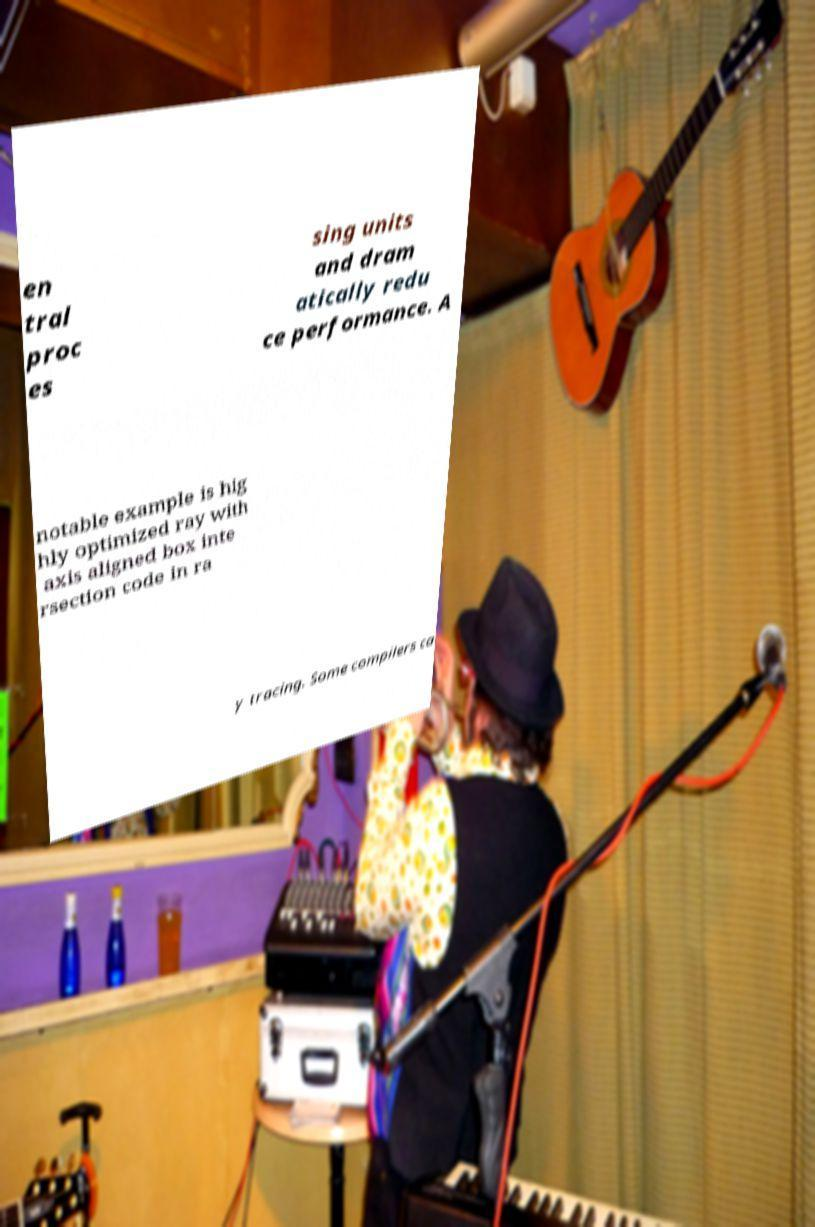For documentation purposes, I need the text within this image transcribed. Could you provide that? en tral proc es sing units and dram atically redu ce performance. A notable example is hig hly optimized ray with axis aligned box inte rsection code in ra y tracing. Some compilers ca 